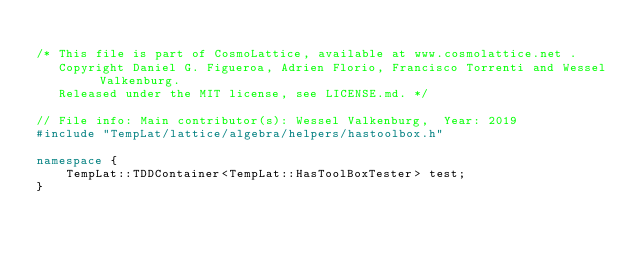Convert code to text. <code><loc_0><loc_0><loc_500><loc_500><_C++_> 
/* This file is part of CosmoLattice, available at www.cosmolattice.net .
   Copyright Daniel G. Figueroa, Adrien Florio, Francisco Torrenti and Wessel Valkenburg.
   Released under the MIT license, see LICENSE.md. */ 
   
// File info: Main contributor(s): Wessel Valkenburg,  Year: 2019
#include "TempLat/lattice/algebra/helpers/hastoolbox.h"

namespace {
    TempLat::TDDContainer<TempLat::HasToolBoxTester> test;
}

</code> 